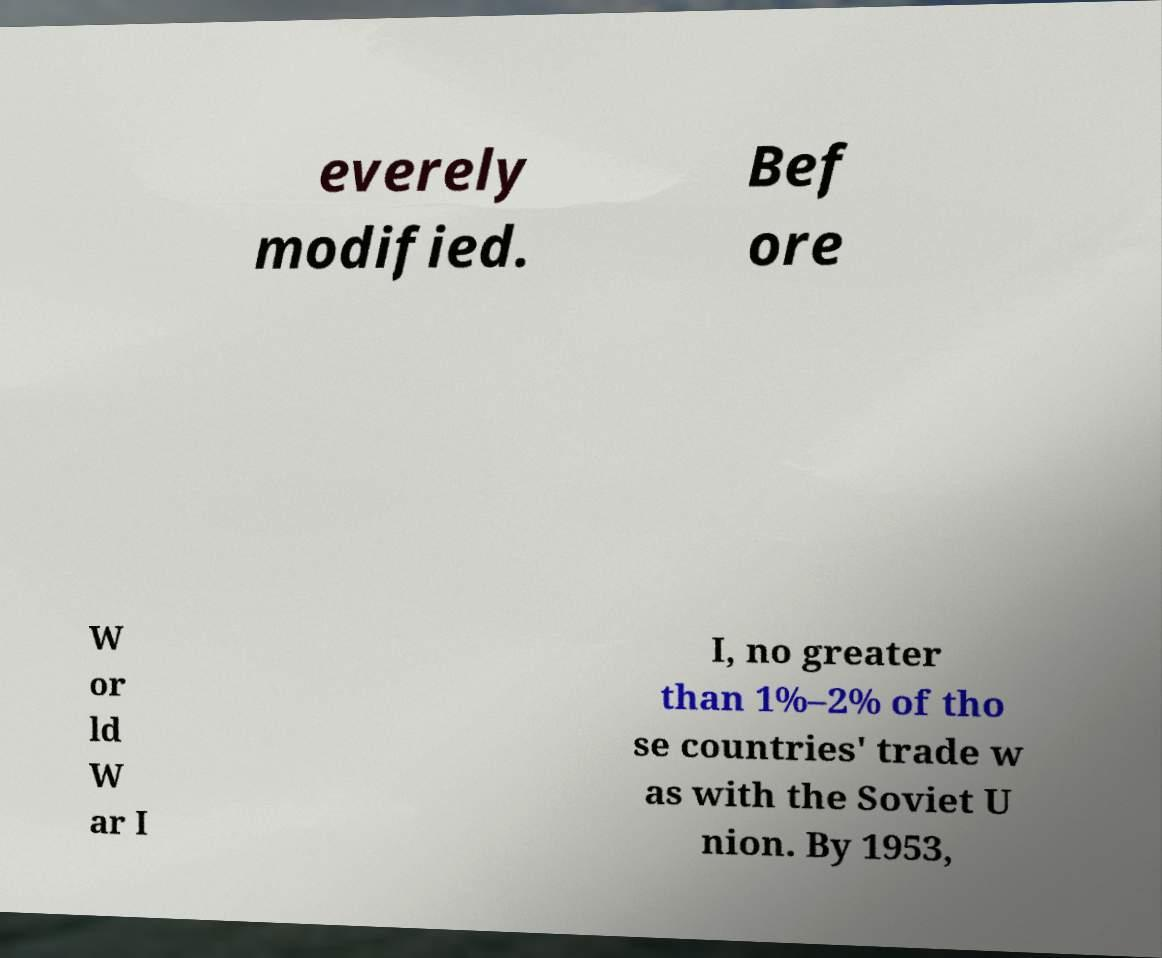Please read and relay the text visible in this image. What does it say? everely modified. Bef ore W or ld W ar I I, no greater than 1%–2% of tho se countries' trade w as with the Soviet U nion. By 1953, 